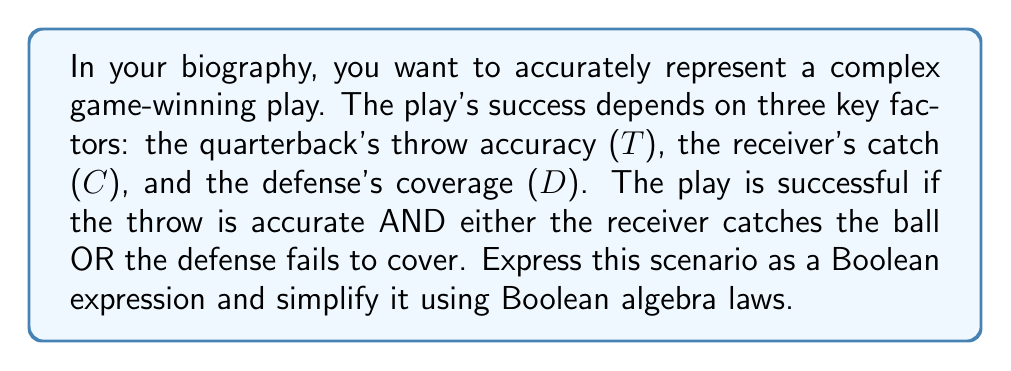Teach me how to tackle this problem. Let's approach this step-by-step:

1) First, we need to express the scenario as a Boolean expression:
   $$(T \land (C \lor \lnot D))$$

   Where:
   $T$ = Throw is accurate
   $C$ = Receiver catches the ball
   $D$ = Defense covers successfully
   $\land$ = AND operator
   $\lor$ = OR operator
   $\lnot$ = NOT operator

2) This expression is already relatively simple, but we can verify if it can be simplified further using Boolean algebra laws.

3) We can apply the distributive law: $A \land (B \lor C) = (A \land B) \lor (A \land C)$

   $$(T \land (C \lor \lnot D)) = (T \land C) \lor (T \land \lnot D)$$

4) This expanded form doesn't simplify the expression further, so our original expression remains the most simplified form.

5) Therefore, the final Boolean expression representing the successful play is:

   $$T \land (C \lor \lnot D)$$

This expression accurately models the complex game scenario where the play's success depends on an accurate throw AND either a successful catch OR unsuccessful defense coverage.
Answer: $$T \land (C \lor \lnot D)$$ 